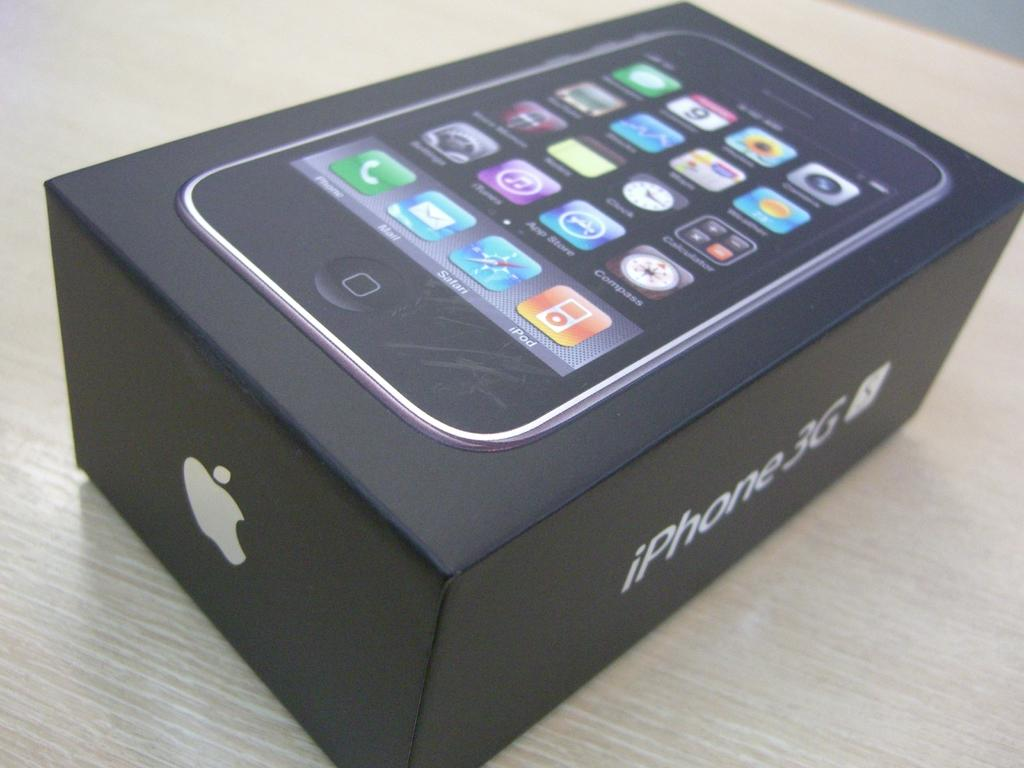Provide a one-sentence caption for the provided image. A black iPhone 3G apple phone box on a counter top. 